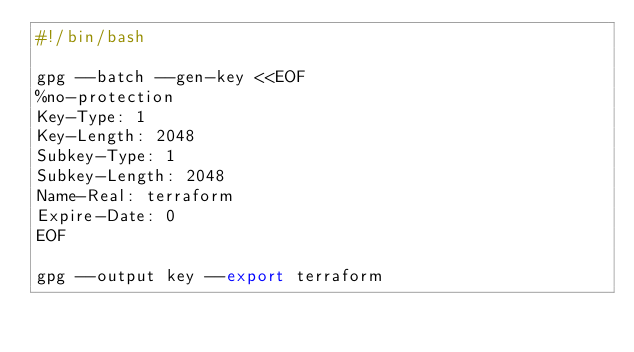Convert code to text. <code><loc_0><loc_0><loc_500><loc_500><_Bash_>#!/bin/bash

gpg --batch --gen-key <<EOF
%no-protection
Key-Type: 1
Key-Length: 2048
Subkey-Type: 1
Subkey-Length: 2048
Name-Real: terraform
Expire-Date: 0
EOF

gpg --output key --export terraform
</code> 